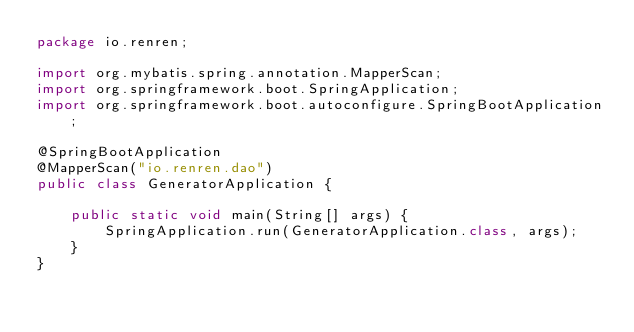<code> <loc_0><loc_0><loc_500><loc_500><_Java_>package io.renren;

import org.mybatis.spring.annotation.MapperScan;
import org.springframework.boot.SpringApplication;
import org.springframework.boot.autoconfigure.SpringBootApplication;

@SpringBootApplication
@MapperScan("io.renren.dao")
public class GeneratorApplication {

	public static void main(String[] args) {
		SpringApplication.run(GeneratorApplication.class, args);
	}
}
</code> 